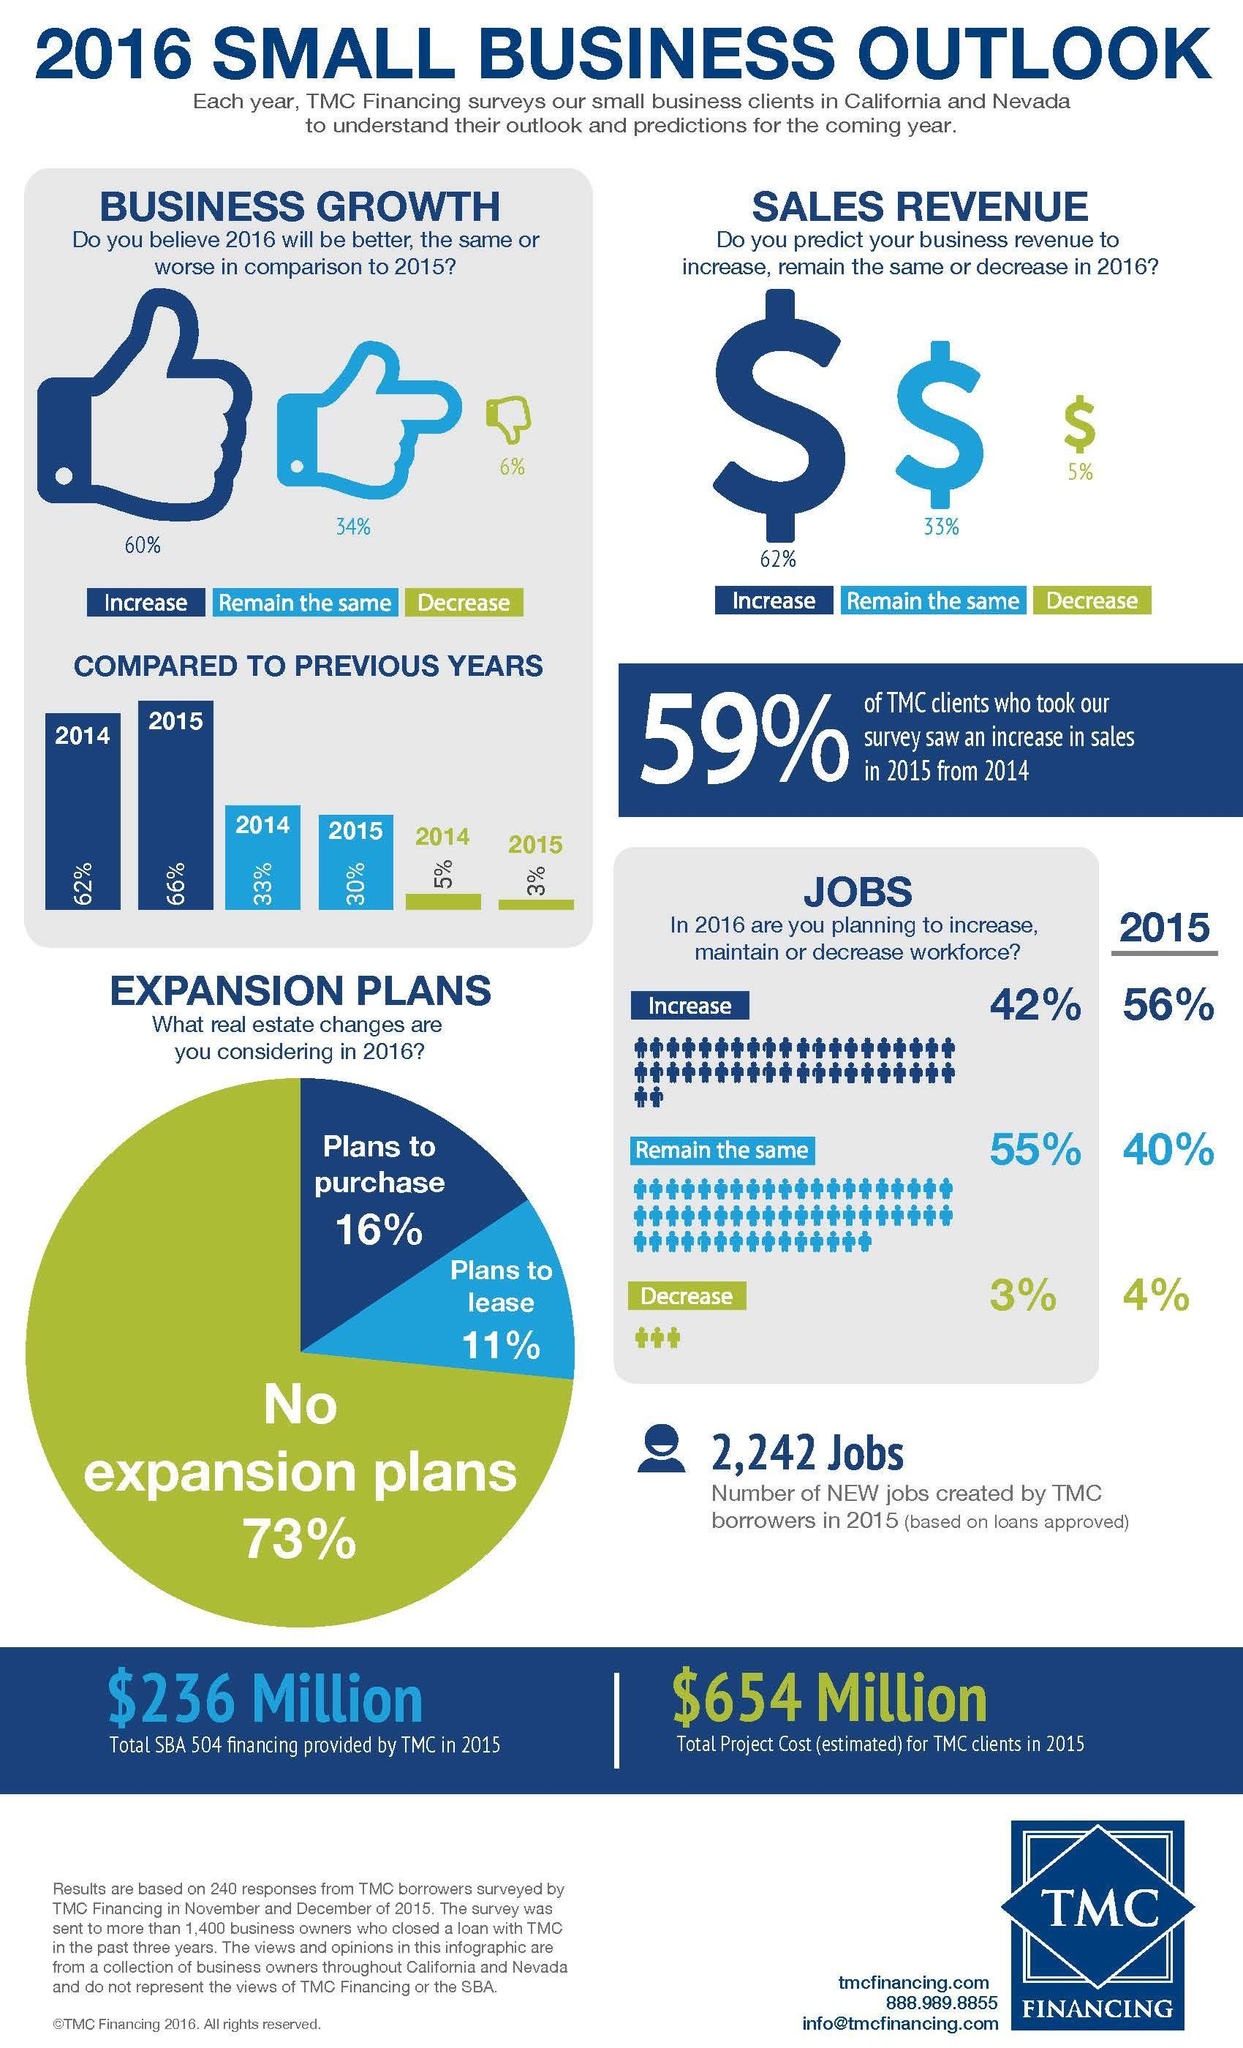Highlight a few significant elements in this photo. According to a recent survey, 60% of respondents believe that business growth will be better in 2016. According to a survey conducted in 2016, 27% of respondents indicated that they planned to both lease and purchase a vehicle in the future. In 2015, 41% of TMC clients experienced a decline in sales compared to the previous year. 